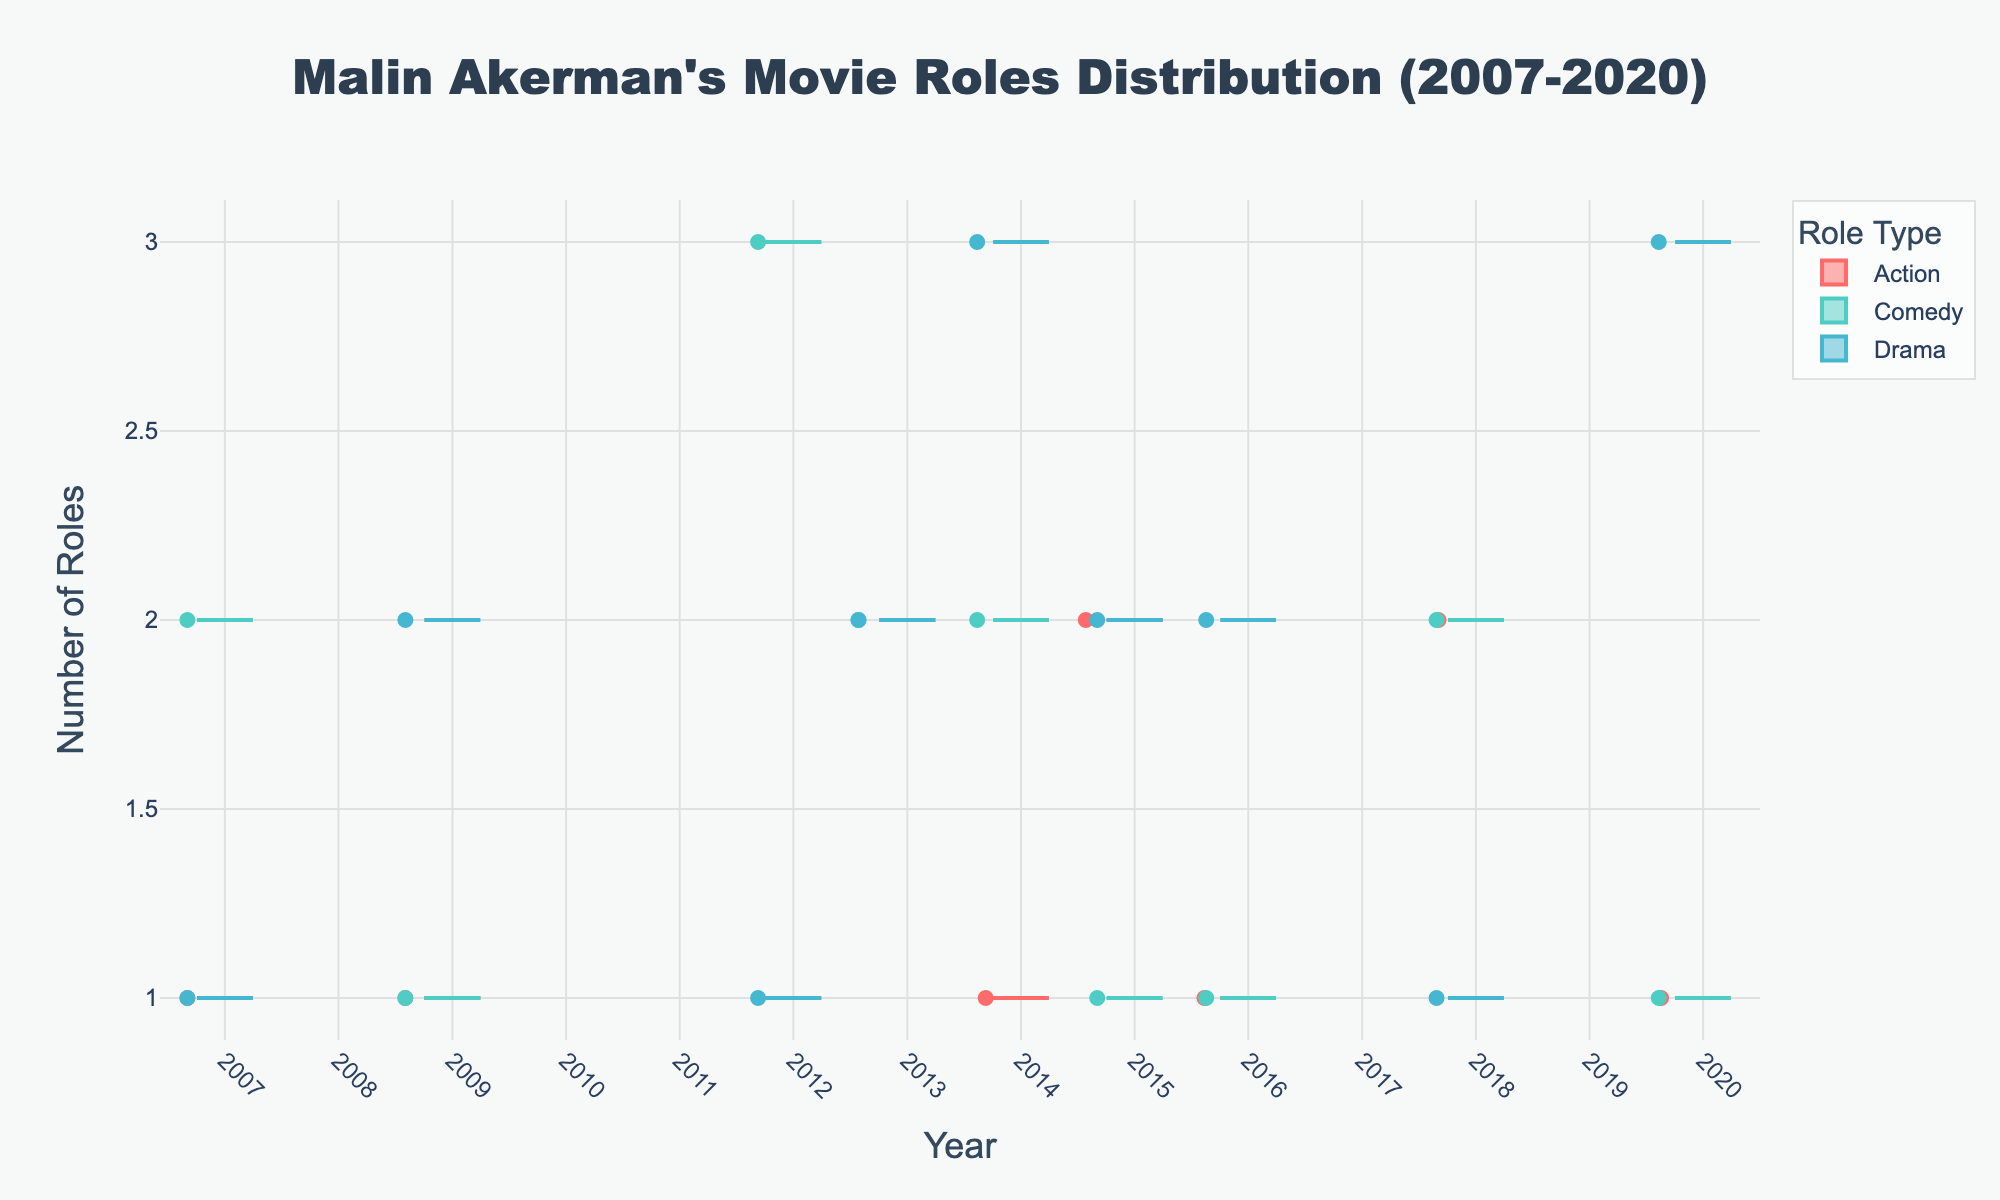What's the title of the figure? The title is usually displayed at the top of the figure. In this case, it should be directly viewable in the plot.
Answer: Malin Akerman's Movie Roles Distribution (2007-2020) How many Action roles was Malin Akerman offered in 2015? By looking at the data points for the year 2015 under the Action category, you can find this information. The plot shows the count with each dot.
Answer: 2 What is the range of Comedy roles offered to Malin Akerman over the years? The range can be determined by identifying the minimum and maximum number of Comedy roles over the displayed years in the plot. Look at the vertical spread of data points in the Comedy category.
Answer: 1 to 3 How did the number of Drama roles change from 2016 to 2020? Compare the data points for Drama roles in 2016 and 2020. You need to see the counts in both years and note the difference.
Answer: Increased from 2 to 3 Which year shows the highest variance in the number of Drama roles offered to Malin Akerman? Identify the year with the widest spread of data points or box in the Drama category. This indicates higher variance.
Answer: 2014 Between Action and Drama roles, which one has a higher median in 2020? Medians are typically shown by a line inside the box plot. Compare the median lines of Action and Drama roles for the year 2020.
Answer: Drama Which role type had the most considerable increase in the number of roles between 2007 and 2020? Compare the number of roles for each type in 2007 and 2020 and determine the type with the biggest difference.
Answer: Drama How consistent were the Comedy roles offered compared to Drama roles? Look at the spread of the data points and the width of the boxes for Comedy vs. Drama; consistency implies a more concentrated or narrow spread.
Answer: Comedy roles were more consistent Which role type had the highest single count in any year? Identify the highest point (dot) in the plot across all role types and years. Look for the peak values in each category.
Answer: Drama 